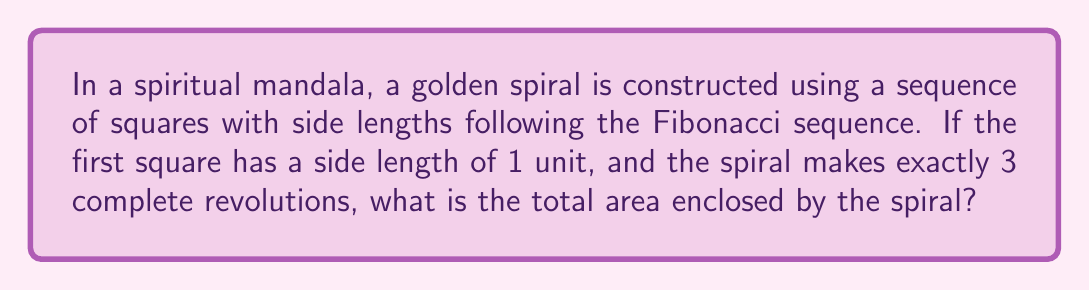Can you answer this question? Let's approach this step-by-step:

1) The Fibonacci sequence starts with 1, 1, and each subsequent number is the sum of the two preceding ones. So the sequence begins: 1, 1, 2, 3, 5, 8, 13, 21, 34, ...

2) To make 3 complete revolutions, we need 12 squares (4 squares per revolution).

3) The side lengths of these 12 squares will be: 1, 1, 2, 3, 5, 8, 13, 21, 34, 55, 89, 144.

4) The area of each square is the square of its side length. So the areas are:
   $$1^2, 1^2, 2^2, 3^2, 5^2, 8^2, 13^2, 21^2, 34^2, 55^2, 89^2, 144^2$$

5) We need to sum these areas:
   $$\sum_{i=1}^{12} F_i^2 = 1 + 1 + 4 + 9 + 25 + 64 + 169 + 441 + 1156 + 3025 + 7921 + 20736$$

6) This sum equals 33,552.

7) However, this is not the exact area enclosed by the spiral. The spiral curves through these squares, leaving some areas out and including some areas between the squares.

8) It can be proven that for a golden spiral, the actual area is approximately 0.7698 times the sum of the squares.

9) Therefore, the area enclosed by the spiral is approximately:
   $$33552 \times 0.7698 \approx 25,826.23$$
Answer: Approximately 25,826.23 square units 